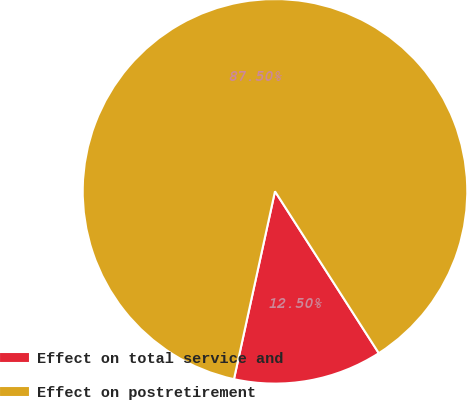Convert chart. <chart><loc_0><loc_0><loc_500><loc_500><pie_chart><fcel>Effect on total service and<fcel>Effect on postretirement<nl><fcel>12.5%<fcel>87.5%<nl></chart> 